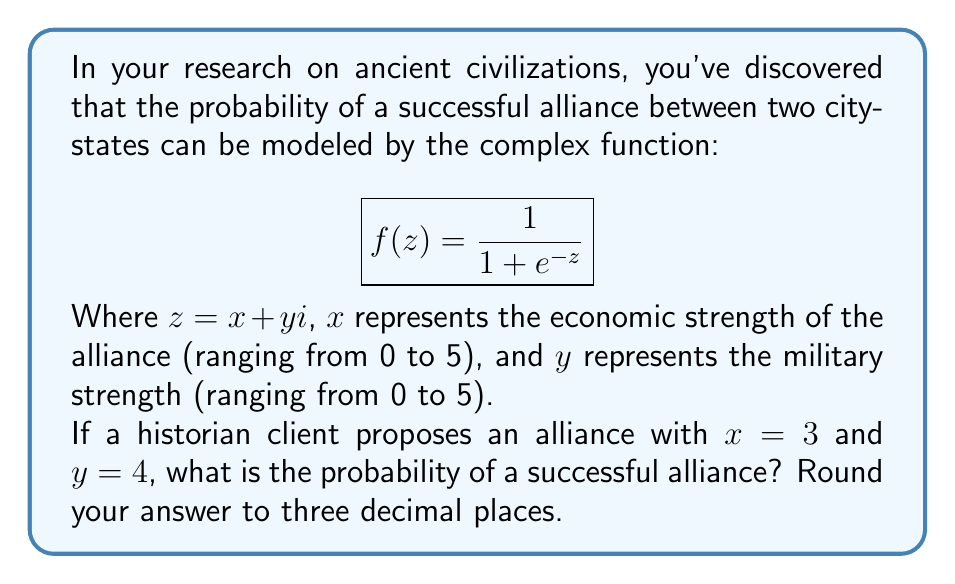Help me with this question. To solve this problem, we need to follow these steps:

1) First, we substitute the given values into our complex number $z$:
   $z = 3 + 4i$

2) Now, we need to calculate $e^{-z}$:
   $e^{-z} = e^{-(3+4i)} = e^{-3} \cdot e^{-4i}$

3) Using Euler's formula, $e^{-4i} = \cos(-4) - i\sin(-4) = \cos(4) + i\sin(4)$

4) So, $e^{-z} = e^{-3}(\cos(4) + i\sin(4))$

5) Now, we can substitute this into our original function:

   $$f(z) = \frac{1}{1 + e^{-3}(\cos(4) + i\sin(4))}$$

6) To simplify this, let's multiply numerator and denominator by the complex conjugate of the denominator:

   $$f(z) = \frac{1 + e^{-3}(\cos(4) - i\sin(4))}{(1 + e^{-3}\cos(4))^2 + (e^{-3}\sin(4))^2}$$

7) The probability is given by the magnitude of this complex number. The magnitude of a complex number $a + bi$ is given by $\sqrt{a^2 + b^2}$. In this case:

   $$|f(z)| = \sqrt{\frac{(1 + e^{-3}\cos(4))^2 + (e^{-3}\sin(4))^2}{((1 + e^{-3}\cos(4))^2 + (e^{-3}\sin(4))^2)^2}}$$

8) Simplify:

   $$|f(z)| = \frac{1}{\sqrt{(1 + e^{-3}\cos(4))^2 + (e^{-3}\sin(4))^2}}$$

9) Calculate the numerical value (using a calculator):

   $$|f(z)| \approx 0.982$$

Thus, the probability of a successful alliance is approximately 0.982 or 98.2%.
Answer: 0.982 